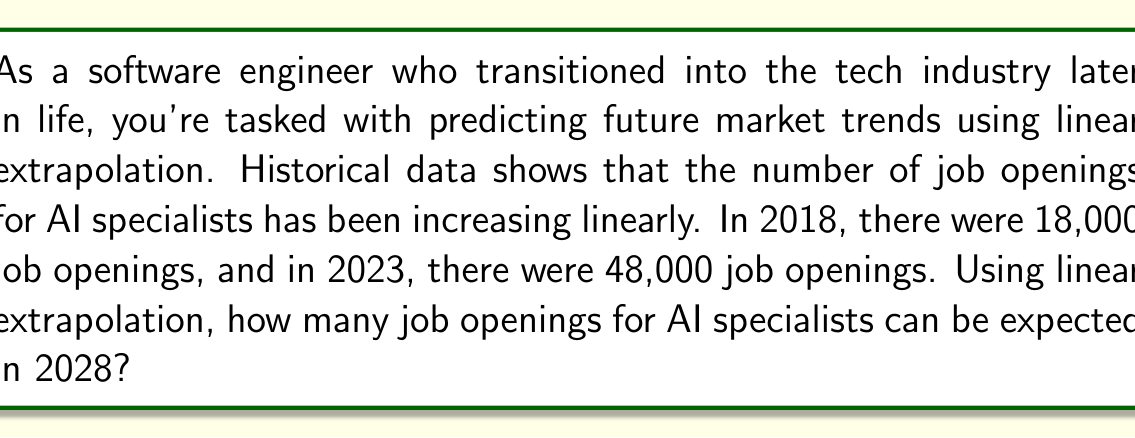Can you solve this math problem? Let's approach this step-by-step using linear extrapolation:

1) First, we need to find the slope of the line. The slope represents the rate of change per year.

   Slope = $\frac{\text{Change in y}}{\text{Change in x}} = \frac{\text{Change in job openings}}{\text{Change in years}}$

2) We have two data points:
   - 2018: 18,000 job openings
   - 2023: 48,000 job openings

3) Calculate the slope:
   $\text{Slope} = \frac{48,000 - 18,000}{2023 - 2018} = \frac{30,000}{5} = 6,000$ job openings per year

4) Now we can use the point-slope form of a line: $y - y_1 = m(x - x_1)$
   Where $(x_1, y_1)$ is a known point, $m$ is the slope, and $(x, y)$ is the point we're looking for.

5) Let's use (2023, 48,000) as our known point:
   $y - 48,000 = 6,000(x - 2023)$

6) We want to find y when x is 2028:
   $y - 48,000 = 6,000(2028 - 2023)$
   $y - 48,000 = 6,000(5)$
   $y - 48,000 = 30,000$
   $y = 78,000$

Therefore, using linear extrapolation, we can expect 78,000 job openings for AI specialists in 2028.
Answer: 78,000 job openings 